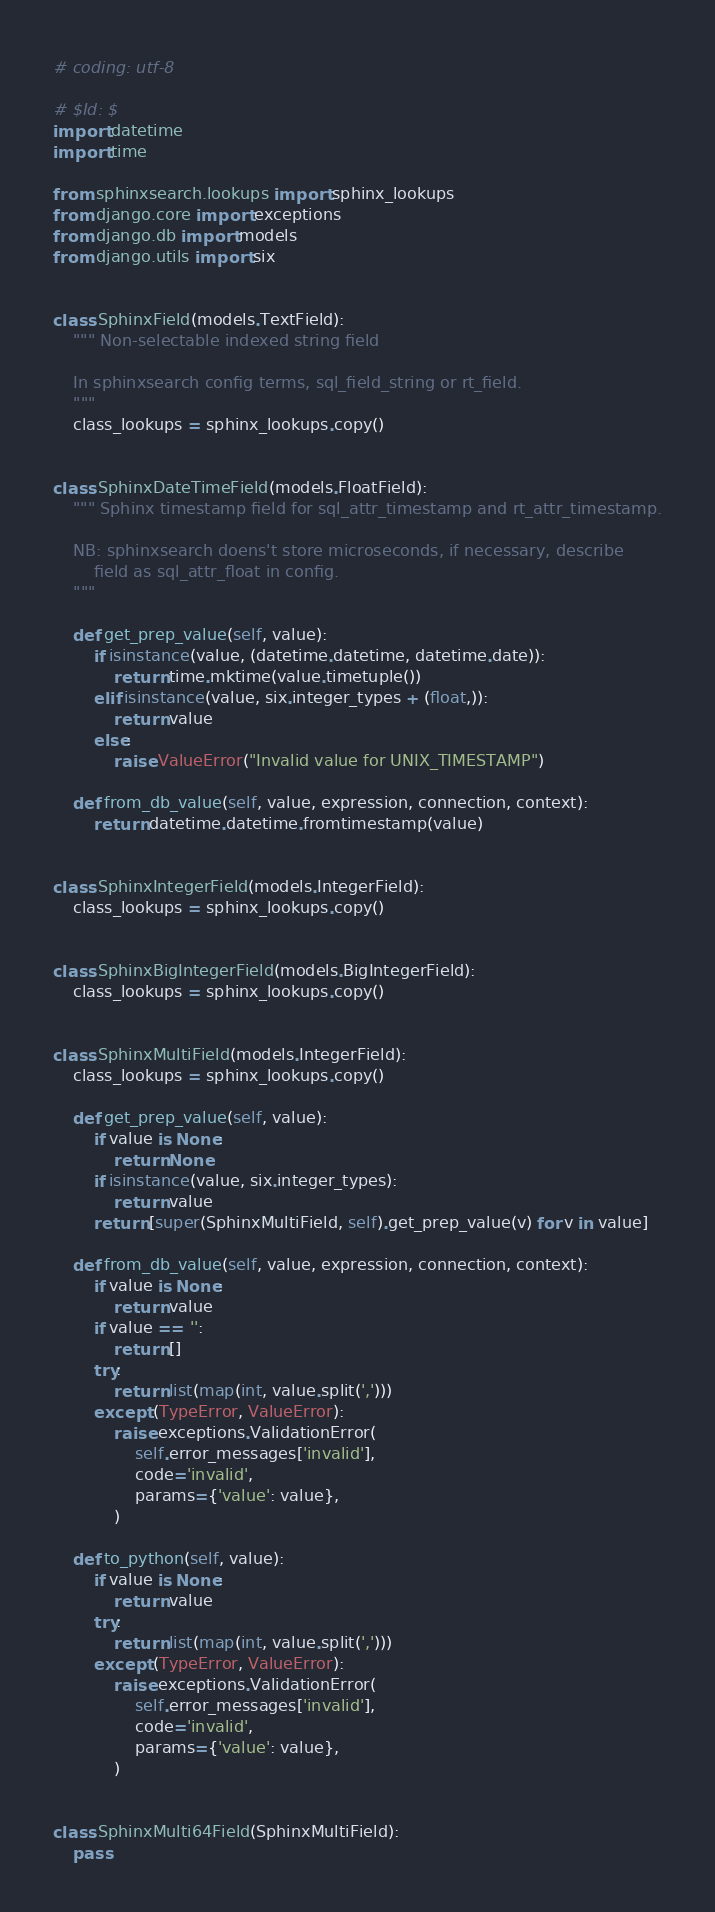Convert code to text. <code><loc_0><loc_0><loc_500><loc_500><_Python_># coding: utf-8

# $Id: $
import datetime
import time

from sphinxsearch.lookups import sphinx_lookups
from django.core import exceptions
from django.db import models
from django.utils import six


class SphinxField(models.TextField):
    """ Non-selectable indexed string field

    In sphinxsearch config terms, sql_field_string or rt_field.
    """
    class_lookups = sphinx_lookups.copy()


class SphinxDateTimeField(models.FloatField):
    """ Sphinx timestamp field for sql_attr_timestamp and rt_attr_timestamp.

    NB: sphinxsearch doens't store microseconds, if necessary, describe
        field as sql_attr_float in config.
    """

    def get_prep_value(self, value):
        if isinstance(value, (datetime.datetime, datetime.date)):
            return time.mktime(value.timetuple())
        elif isinstance(value, six.integer_types + (float,)):
            return value
        else:
            raise ValueError("Invalid value for UNIX_TIMESTAMP")

    def from_db_value(self, value, expression, connection, context):
        return datetime.datetime.fromtimestamp(value)


class SphinxIntegerField(models.IntegerField):
    class_lookups = sphinx_lookups.copy()


class SphinxBigIntegerField(models.BigIntegerField):
    class_lookups = sphinx_lookups.copy()


class SphinxMultiField(models.IntegerField):
    class_lookups = sphinx_lookups.copy()

    def get_prep_value(self, value):
        if value is None:
            return None
        if isinstance(value, six.integer_types):
            return value
        return [super(SphinxMultiField, self).get_prep_value(v) for v in value]

    def from_db_value(self, value, expression, connection, context):
        if value is None:
            return value
        if value == '':
            return []
        try:
            return list(map(int, value.split(',')))
        except (TypeError, ValueError):
            raise exceptions.ValidationError(
                self.error_messages['invalid'],
                code='invalid',
                params={'value': value},
            )

    def to_python(self, value):
        if value is None:
            return value
        try:
            return list(map(int, value.split(',')))
        except (TypeError, ValueError):
            raise exceptions.ValidationError(
                self.error_messages['invalid'],
                code='invalid',
                params={'value': value},
            )


class SphinxMulti64Field(SphinxMultiField):
    pass</code> 